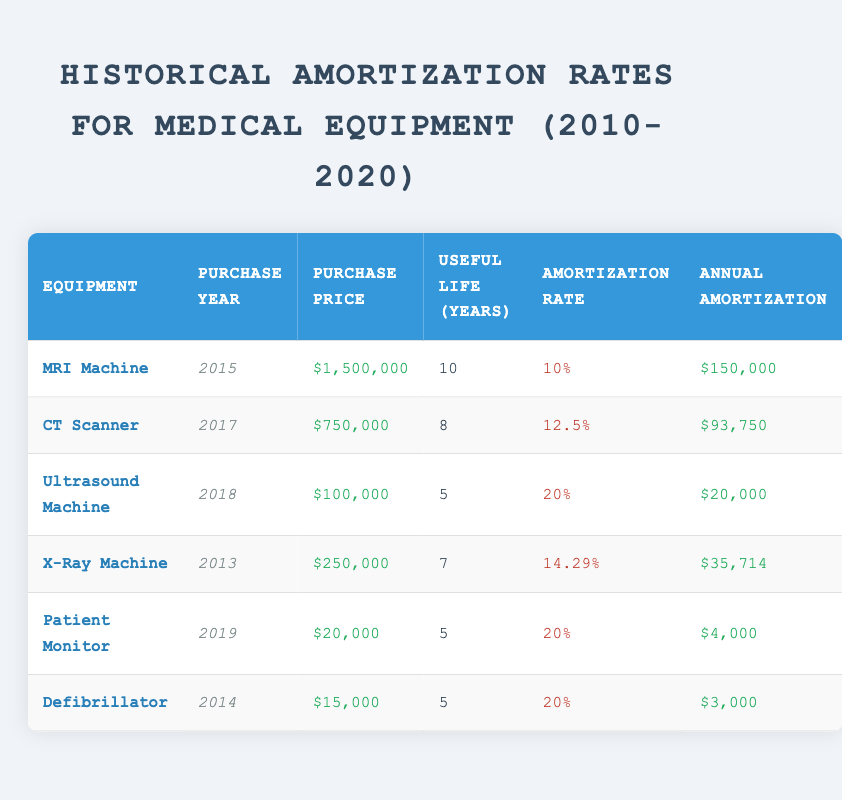What is the purchase price of the MRI Machine? The table shows the row for the MRI Machine, which lists the purchase price. The value indicated is $1,500,000.
Answer: $1,500,000 What is the useful life of the CT Scanner? By looking at the CT Scanner's row in the table, the useful life is listed as 8 years.
Answer: 8 years How much is the annual amortization for the Ultrasound Machine? The table specifies that the annual amortization for the Ultrasound Machine is $20,000.
Answer: $20,000 Which equipment has the highest amortization rate? To find the highest amortization rate, we can compare all rates listed in the table. The Ultrasound Machine has the highest rate of 20%.
Answer: Ultrasound Machine What is the total purchase price for all medical equipment listed? We need to sum the purchase prices of all items: $1,500,000 (MRI) + $750,000 (CT) + $100,000 (Ultrasound) + $250,000 (X-Ray) + $20,000 (Patient Monitor) + $15,000 (Defibrillator) = $2,635,000.
Answer: $2,635,000 Does the Patient Monitor have a longer useful life than the Defibrillator? The useful life of the Patient Monitor is 5 years, while the Defibrillator also has a useful life of 5 years, which means they are equal. Therefore, the statement is false.
Answer: No What is the average annual amortization for all equipment? First, we sum up the annual amortization values: $150,000 (MRI) + $93,750 (CT) + $20,000 (Ultrasound) + $35,714 (X-Ray) + $4,000 (Patient Monitor) + $3,000 (Defibrillator) = $305,464. Then divide by 6 (the number of items): $305,464 / 6 ≈ $50,911.67.
Answer: Approximately $50,911.67 Is the purchase price of the X-Ray Machine less than $300,000? The purchase price of the X-Ray Machine is $250,000, which is indeed less than $300,000. Hence, the statement is true.
Answer: Yes Which medical equipment's annual amortization is closest to $10,000? The annual amortization for each machine is compared; the closest to $10,000 is the Defibrillator at $3,000, but it is not very close. Hence, there is no exact match, but the Defibrillator is the nearest.
Answer: Defibrillator 